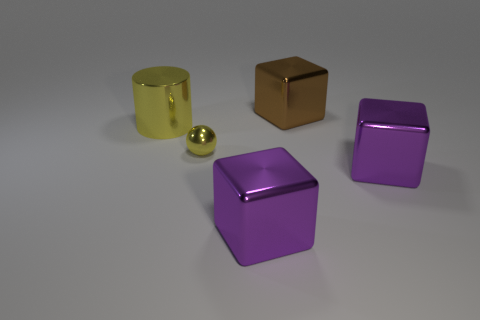Add 1 large purple matte blocks. How many objects exist? 6 Subtract all cylinders. How many objects are left? 4 Add 5 brown metallic objects. How many brown metallic objects are left? 6 Add 2 big shiny cylinders. How many big shiny cylinders exist? 3 Subtract 0 brown spheres. How many objects are left? 5 Subtract all tiny purple metal cubes. Subtract all big purple metal cubes. How many objects are left? 3 